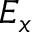<formula> <loc_0><loc_0><loc_500><loc_500>E _ { x }</formula> 